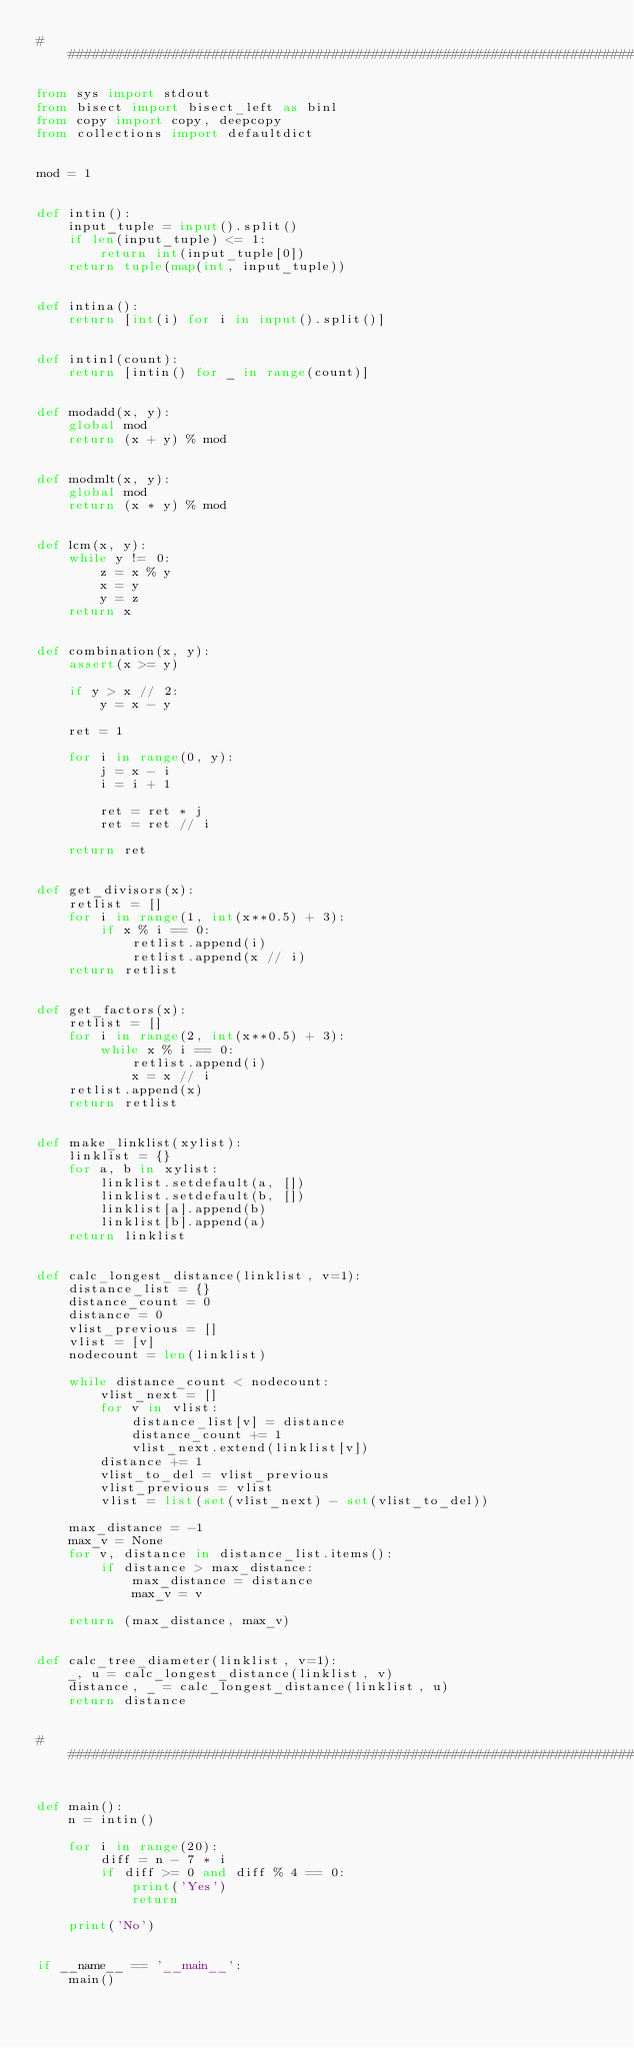<code> <loc_0><loc_0><loc_500><loc_500><_Python_>###############################################################################

from sys import stdout
from bisect import bisect_left as binl
from copy import copy, deepcopy
from collections import defaultdict


mod = 1


def intin():
    input_tuple = input().split()
    if len(input_tuple) <= 1:
        return int(input_tuple[0])
    return tuple(map(int, input_tuple))


def intina():
    return [int(i) for i in input().split()]


def intinl(count):
    return [intin() for _ in range(count)]


def modadd(x, y):
    global mod
    return (x + y) % mod


def modmlt(x, y):
    global mod
    return (x * y) % mod


def lcm(x, y):
    while y != 0:
        z = x % y
        x = y
        y = z
    return x


def combination(x, y):
    assert(x >= y)

    if y > x // 2:
        y = x - y

    ret = 1

    for i in range(0, y):
        j = x - i
        i = i + 1

        ret = ret * j
        ret = ret // i

    return ret


def get_divisors(x):
    retlist = []
    for i in range(1, int(x**0.5) + 3):
        if x % i == 0:
            retlist.append(i)
            retlist.append(x // i)
    return retlist


def get_factors(x):
    retlist = []
    for i in range(2, int(x**0.5) + 3):
        while x % i == 0:
            retlist.append(i)
            x = x // i
    retlist.append(x)
    return retlist


def make_linklist(xylist):
    linklist = {}
    for a, b in xylist:
        linklist.setdefault(a, [])
        linklist.setdefault(b, [])
        linklist[a].append(b)
        linklist[b].append(a)
    return linklist


def calc_longest_distance(linklist, v=1):
    distance_list = {}
    distance_count = 0
    distance = 0
    vlist_previous = []
    vlist = [v]
    nodecount = len(linklist)

    while distance_count < nodecount:
        vlist_next = []
        for v in vlist:
            distance_list[v] = distance
            distance_count += 1
            vlist_next.extend(linklist[v])
        distance += 1
        vlist_to_del = vlist_previous
        vlist_previous = vlist
        vlist = list(set(vlist_next) - set(vlist_to_del))

    max_distance = -1
    max_v = None
    for v, distance in distance_list.items():
        if distance > max_distance:
            max_distance = distance
            max_v = v

    return (max_distance, max_v)


def calc_tree_diameter(linklist, v=1):
    _, u = calc_longest_distance(linklist, v)
    distance, _ = calc_longest_distance(linklist, u)
    return distance


###############################################################################


def main():
    n = intin()

    for i in range(20):
        diff = n - 7 * i
        if diff >= 0 and diff % 4 == 0:
            print('Yes')
            return

    print('No')


if __name__ == '__main__':
    main()
</code> 